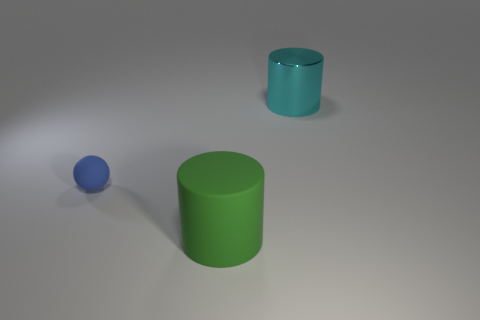Does the matte object in front of the small blue matte thing have the same size as the object on the right side of the green rubber cylinder?
Keep it short and to the point. Yes. What shape is the large object to the left of the big cyan metal thing?
Your response must be concise. Cylinder. There is a thing that is in front of the thing that is on the left side of the large green object; what is its material?
Your answer should be very brief. Rubber. Are there any cylinders that have the same color as the large rubber thing?
Provide a succinct answer. No. There is a cyan metallic cylinder; is it the same size as the green rubber object that is on the right side of the small rubber sphere?
Provide a short and direct response. Yes. There is a big cylinder on the left side of the large thing behind the tiny matte object; how many big cyan cylinders are in front of it?
Offer a very short reply. 0. What number of matte balls are to the left of the cyan cylinder?
Your response must be concise. 1. There is a rubber thing on the left side of the cylinder that is in front of the tiny blue rubber sphere; what color is it?
Make the answer very short. Blue. What number of other things are the same material as the blue ball?
Your response must be concise. 1. Is the number of large matte cylinders that are behind the blue matte ball the same as the number of small green blocks?
Provide a succinct answer. Yes. 